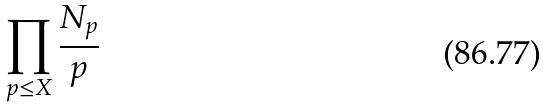<formula> <loc_0><loc_0><loc_500><loc_500>\prod _ { p \leq X } \frac { N _ { p } } { p }</formula> 